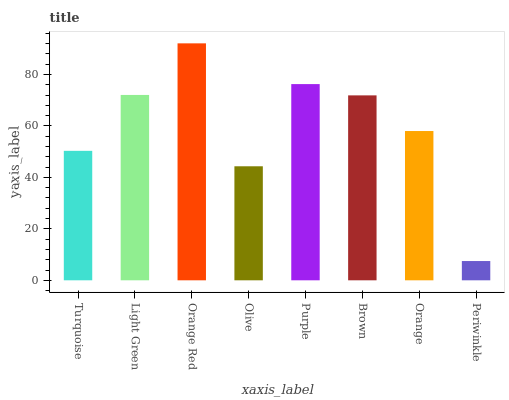Is Periwinkle the minimum?
Answer yes or no. Yes. Is Orange Red the maximum?
Answer yes or no. Yes. Is Light Green the minimum?
Answer yes or no. No. Is Light Green the maximum?
Answer yes or no. No. Is Light Green greater than Turquoise?
Answer yes or no. Yes. Is Turquoise less than Light Green?
Answer yes or no. Yes. Is Turquoise greater than Light Green?
Answer yes or no. No. Is Light Green less than Turquoise?
Answer yes or no. No. Is Brown the high median?
Answer yes or no. Yes. Is Orange the low median?
Answer yes or no. Yes. Is Turquoise the high median?
Answer yes or no. No. Is Periwinkle the low median?
Answer yes or no. No. 